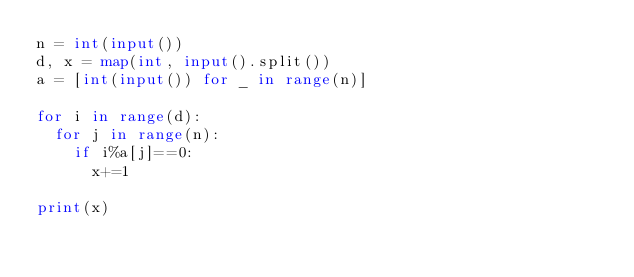Convert code to text. <code><loc_0><loc_0><loc_500><loc_500><_Python_>n = int(input())
d, x = map(int, input().split())
a = [int(input()) for _ in range(n)]

for i in range(d):
  for j in range(n):
    if i%a[j]==0:
      x+=1

print(x)</code> 